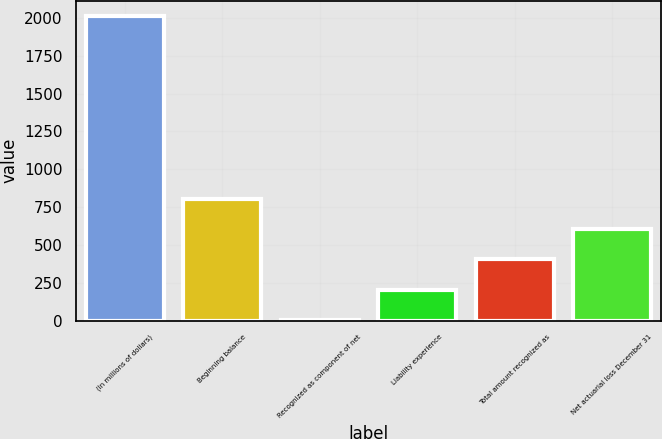Convert chart. <chart><loc_0><loc_0><loc_500><loc_500><bar_chart><fcel>(In millions of dollars)<fcel>Beginning balance<fcel>Recognized as component of net<fcel>Liability experience<fcel>Total amount recognized as<fcel>Net actuarial loss December 31<nl><fcel>2013<fcel>806.4<fcel>2<fcel>203.1<fcel>404.2<fcel>605.3<nl></chart> 